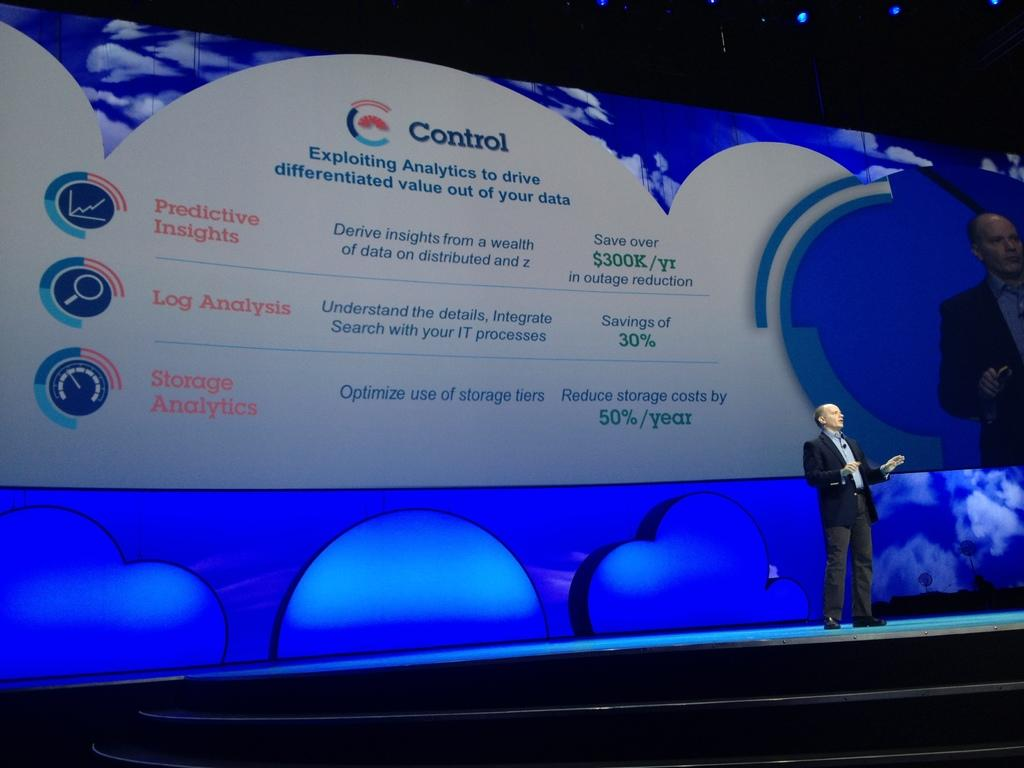<image>
Summarize the visual content of the image. A man on a stage while a large screen shows up behind him with ways to control and IT processes information. 